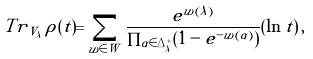<formula> <loc_0><loc_0><loc_500><loc_500>T r _ { \, V _ { \lambda } } \, \rho ( t ) = \sum _ { w \in W } \frac { e ^ { w ( \lambda ) } } { \prod _ { \alpha \in \Delta _ { \lambda } ^ { + } } ( 1 - e ^ { - w ( \alpha ) } ) } ( \ln t ) \, ,</formula> 